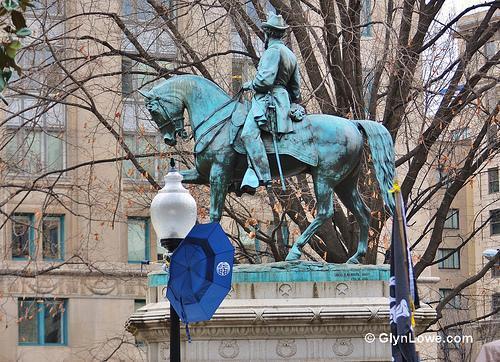How many lamps are there?
Give a very brief answer. 1. 